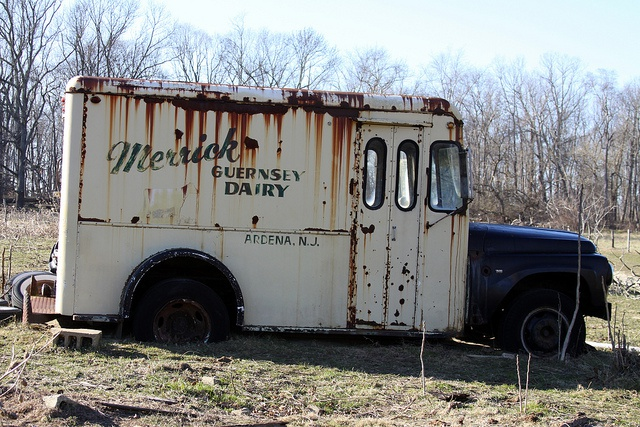Describe the objects in this image and their specific colors. I can see a truck in lavender, gray, and black tones in this image. 